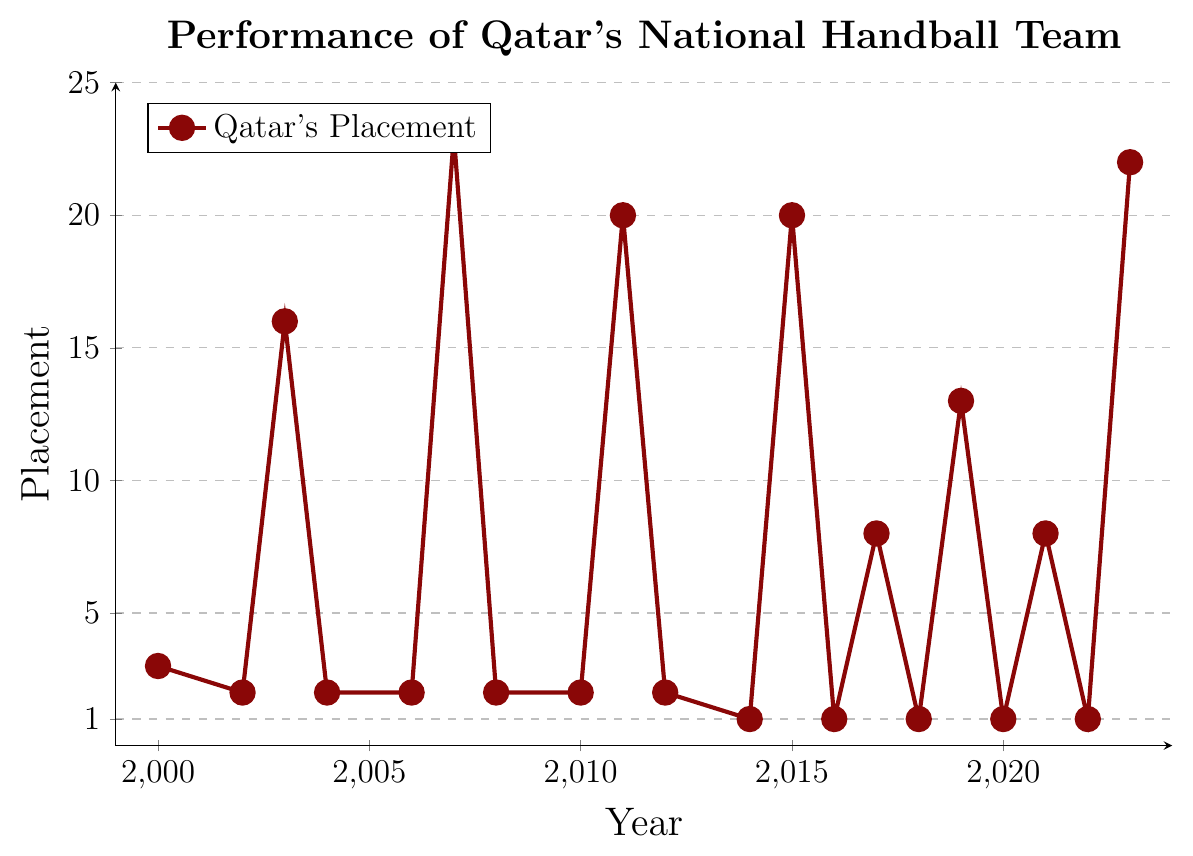Which year did Qatar's national handball team achieve its best performance in the data? The best performance is indicated by the lowest placement value on the plot. The lowest placement is 1, which occurs in the years 2014, 2016, 2018, 2020, and 2022.
Answer: 2014, 2016, 2018, 2020, 2022 How did the team's performance in the World Championship change from 2017 to 2023? From 2017 to 2023, the team's placement in the World Championship goes from 8 in 2017, to 13 in 2019, and then to 22 in 2023.
Answer: The performance declined Which tournament has Qatar consistently performed the best in? The best performance is indicated by lower placement values, and we see that in the tournaments: Asian Championship and Asian Games. Consistently getting placements such as 1st and 2nd.
Answer: Asian Championship and Asian Games Did Qatar's national handball team achieve their worst performance in a World Championship or an Asian tournament? The worst performance is indicated by the highest placement value. The highest placement is 23, recorded in the 2007 World Championship.
Answer: World Championship Between 2010 and 2023, in which year was there the most significant improvement or decline in the team's performance? Significant improvement or decline can be identified by the largest change in placement values between consecutive years. From 2011 (20) to 2012 (2) is an improvement of 18 places.
Answer: 2012 What was the team's average placement in the World Championships during the provided period? The team's placements in the World Championships are: 16, 23, 20, 20, 8, 13, 8, 22. The average is calculated as (16 + 23 + 20 + 20 + 8 + 13 + 8 + 22)/8.
Answer: 16.25 How many times did Qatar's handball team achieve first place in any tournament from 2000 to 2023? First place is indicated by a placement value of 1. The team achieved first place in the years 2014, 2016, 2018, 2020, and 2022.
Answer: 5 times What is the range of placements Qatar's team achieved in Asian tournaments? The range is calculated by subtracting the lowest placement value from the highest placement value. In Asian tournaments, the placements are 1, 2, and 3. The range is 3 - 1.
Answer: 2 Which year showed the greatest improvement in placement between two consecutive World Championships? The greatest improvement is indicated by the largest decrease in placement values between consecutive years. Between the 2015 (20) and 2017 (8) World Championships, the improvement is 12 places.
Answer: 2017 